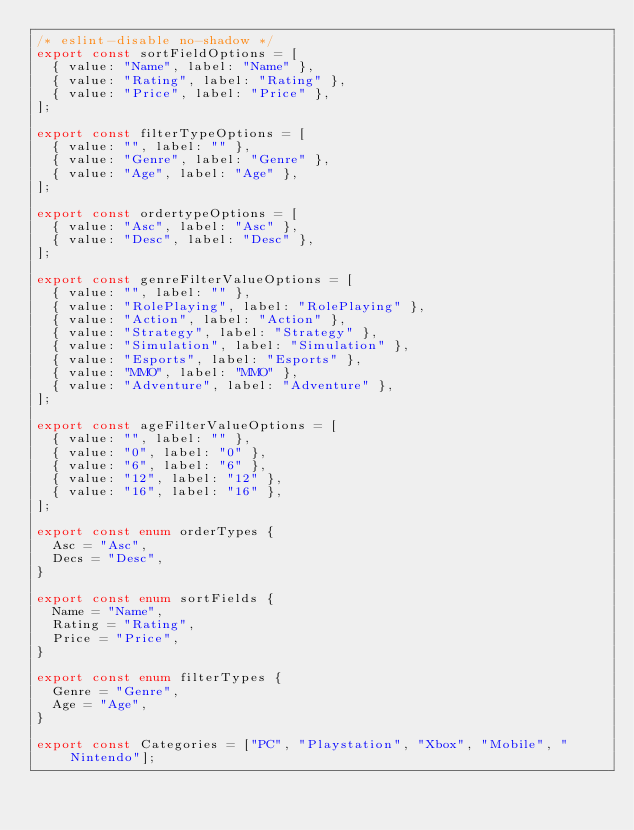<code> <loc_0><loc_0><loc_500><loc_500><_TypeScript_>/* eslint-disable no-shadow */
export const sortFieldOptions = [
  { value: "Name", label: "Name" },
  { value: "Rating", label: "Rating" },
  { value: "Price", label: "Price" },
];

export const filterTypeOptions = [
  { value: "", label: "" },
  { value: "Genre", label: "Genre" },
  { value: "Age", label: "Age" },
];

export const ordertypeOptions = [
  { value: "Asc", label: "Asc" },
  { value: "Desc", label: "Desc" },
];

export const genreFilterValueOptions = [
  { value: "", label: "" },
  { value: "RolePlaying", label: "RolePlaying" },
  { value: "Action", label: "Action" },
  { value: "Strategy", label: "Strategy" },
  { value: "Simulation", label: "Simulation" },
  { value: "Esports", label: "Esports" },
  { value: "MMO", label: "MMO" },
  { value: "Adventure", label: "Adventure" },
];

export const ageFilterValueOptions = [
  { value: "", label: "" },
  { value: "0", label: "0" },
  { value: "6", label: "6" },
  { value: "12", label: "12" },
  { value: "16", label: "16" },
];

export const enum orderTypes {
  Asc = "Asc",
  Decs = "Desc",
}

export const enum sortFields {
  Name = "Name",
  Rating = "Rating",
  Price = "Price",
}

export const enum filterTypes {
  Genre = "Genre",
  Age = "Age",
}

export const Categories = ["PC", "Playstation", "Xbox", "Mobile", "Nintendo"];
</code> 